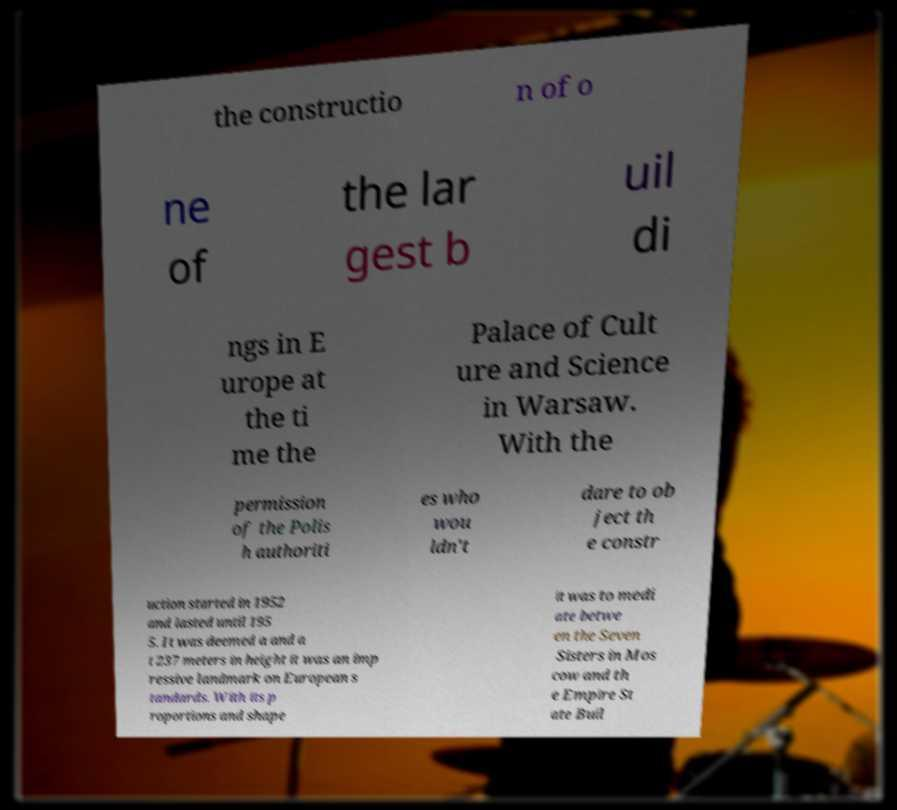Please read and relay the text visible in this image. What does it say? the constructio n of o ne of the lar gest b uil di ngs in E urope at the ti me the Palace of Cult ure and Science in Warsaw. With the permission of the Polis h authoriti es who wou ldn't dare to ob ject th e constr uction started in 1952 and lasted until 195 5. It was deemed a and a t 237 meters in height it was an imp ressive landmark on European s tandards. With its p roportions and shape it was to medi ate betwe en the Seven Sisters in Mos cow and th e Empire St ate Buil 